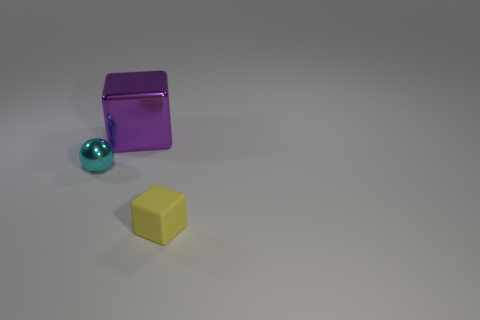How many objects are either large blue matte spheres or cubes? In the image, there is one large matte sphere that is turquoise in color and two cubes; one is purple and the other is yellow. There are no large blue matte spheres or cubes. However, if we include the turquoise sphere as a variation of blue, the total would be three objects. 